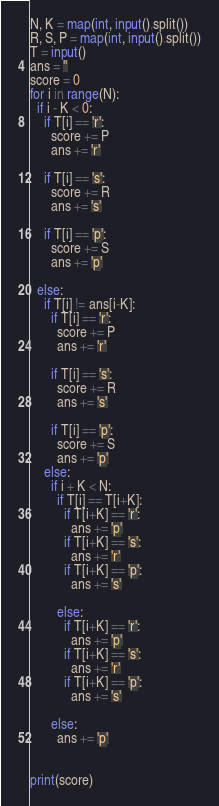Convert code to text. <code><loc_0><loc_0><loc_500><loc_500><_Python_>N, K = map(int, input().split())
R, S, P = map(int, input().split())
T = input()
ans = ''
score = 0
for i in range(N):
  if i - K < 0:
    if T[i] == 'r':
      score += P
      ans += 'r'

    if T[i] == 's':
      score += R
      ans += 's'

    if T[i] == 'p':
      score += S
      ans += 'p'

  else:
    if T[i] != ans[i-K]:
      if T[i] == 'r':
        score += P
        ans += 'r'

      if T[i] == 's':
        score += R
        ans += 's'

      if T[i] == 'p':
        score += S
        ans += 'p'
    else:
      if i + K < N:
        if T[i] == T[i+K]:
          if T[i+K] == 'r':
            ans += 'p'
          if T[i+K] == 's':
            ans += 'r'
          if T[i+K] == 'p':
            ans += 's'

        else:
          if T[i+K] == 'r':
            ans += 'p'
          if T[i+K] == 's':
            ans += 'r'
          if T[i+K] == 'p':
            ans += 's'

      else:
        ans += 'p'


print(score)</code> 